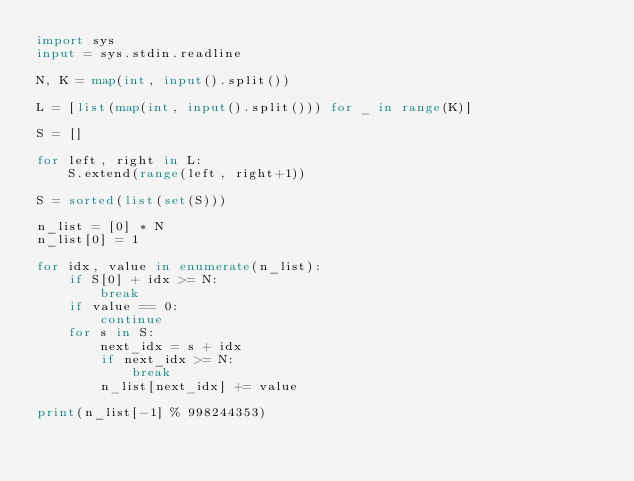Convert code to text. <code><loc_0><loc_0><loc_500><loc_500><_Python_>import sys
input = sys.stdin.readline

N, K = map(int, input().split())

L = [list(map(int, input().split())) for _ in range(K)]

S = []

for left, right in L:
    S.extend(range(left, right+1))

S = sorted(list(set(S)))

n_list = [0] * N
n_list[0] = 1

for idx, value in enumerate(n_list):
    if S[0] + idx >= N:
        break
    if value == 0:
        continue
    for s in S:
        next_idx = s + idx
        if next_idx >= N:
            break
        n_list[next_idx] += value

print(n_list[-1] % 998244353)
</code> 